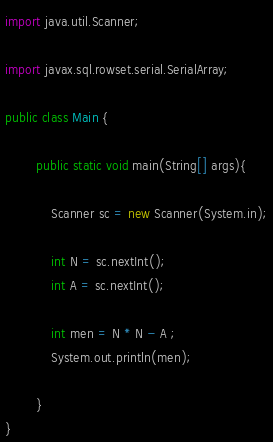Convert code to text. <code><loc_0><loc_0><loc_500><loc_500><_Java_>import java.util.Scanner;

import javax.sql.rowset.serial.SerialArray;

public class Main {

		public static void main(String[] args){
			
			Scanner sc = new Scanner(System.in);

			int N = sc.nextInt();
			int A = sc.nextInt();
			
			int men = N * N - A ;
		    System.out.println(men);

		}
}
</code> 